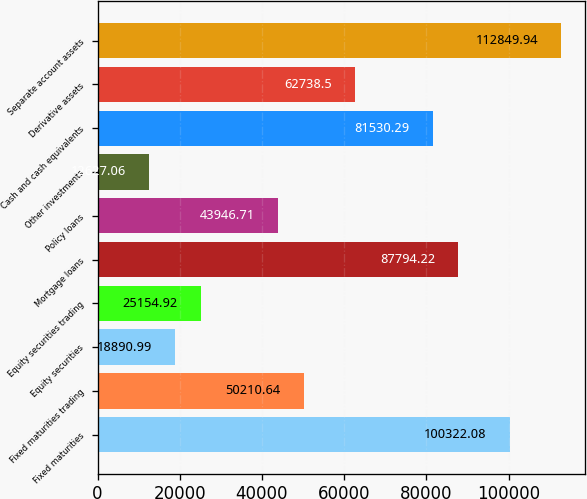Convert chart to OTSL. <chart><loc_0><loc_0><loc_500><loc_500><bar_chart><fcel>Fixed maturities<fcel>Fixed maturities trading<fcel>Equity securities<fcel>Equity securities trading<fcel>Mortgage loans<fcel>Policy loans<fcel>Other investments<fcel>Cash and cash equivalents<fcel>Derivative assets<fcel>Separate account assets<nl><fcel>100322<fcel>50210.6<fcel>18891<fcel>25154.9<fcel>87794.2<fcel>43946.7<fcel>12627.1<fcel>81530.3<fcel>62738.5<fcel>112850<nl></chart> 